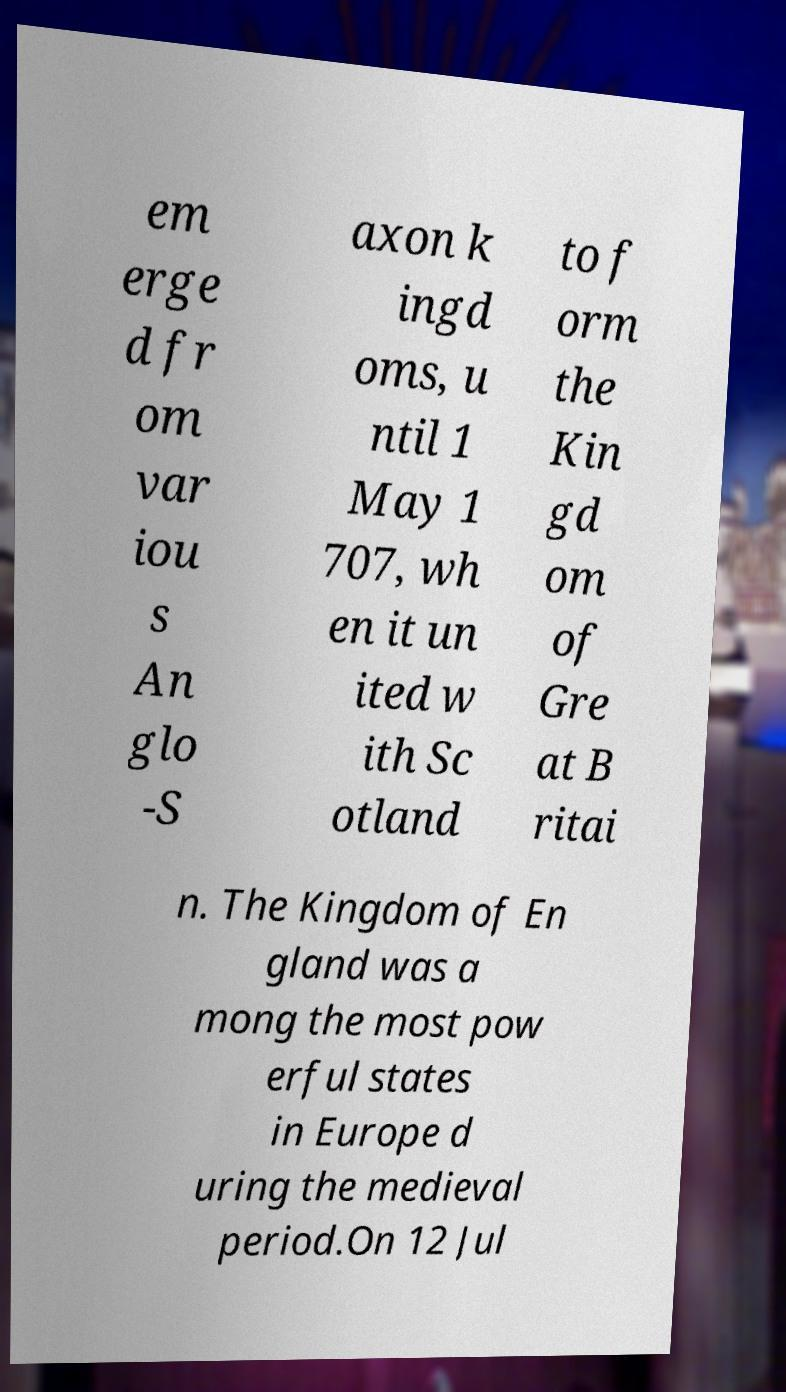I need the written content from this picture converted into text. Can you do that? em erge d fr om var iou s An glo -S axon k ingd oms, u ntil 1 May 1 707, wh en it un ited w ith Sc otland to f orm the Kin gd om of Gre at B ritai n. The Kingdom of En gland was a mong the most pow erful states in Europe d uring the medieval period.On 12 Jul 